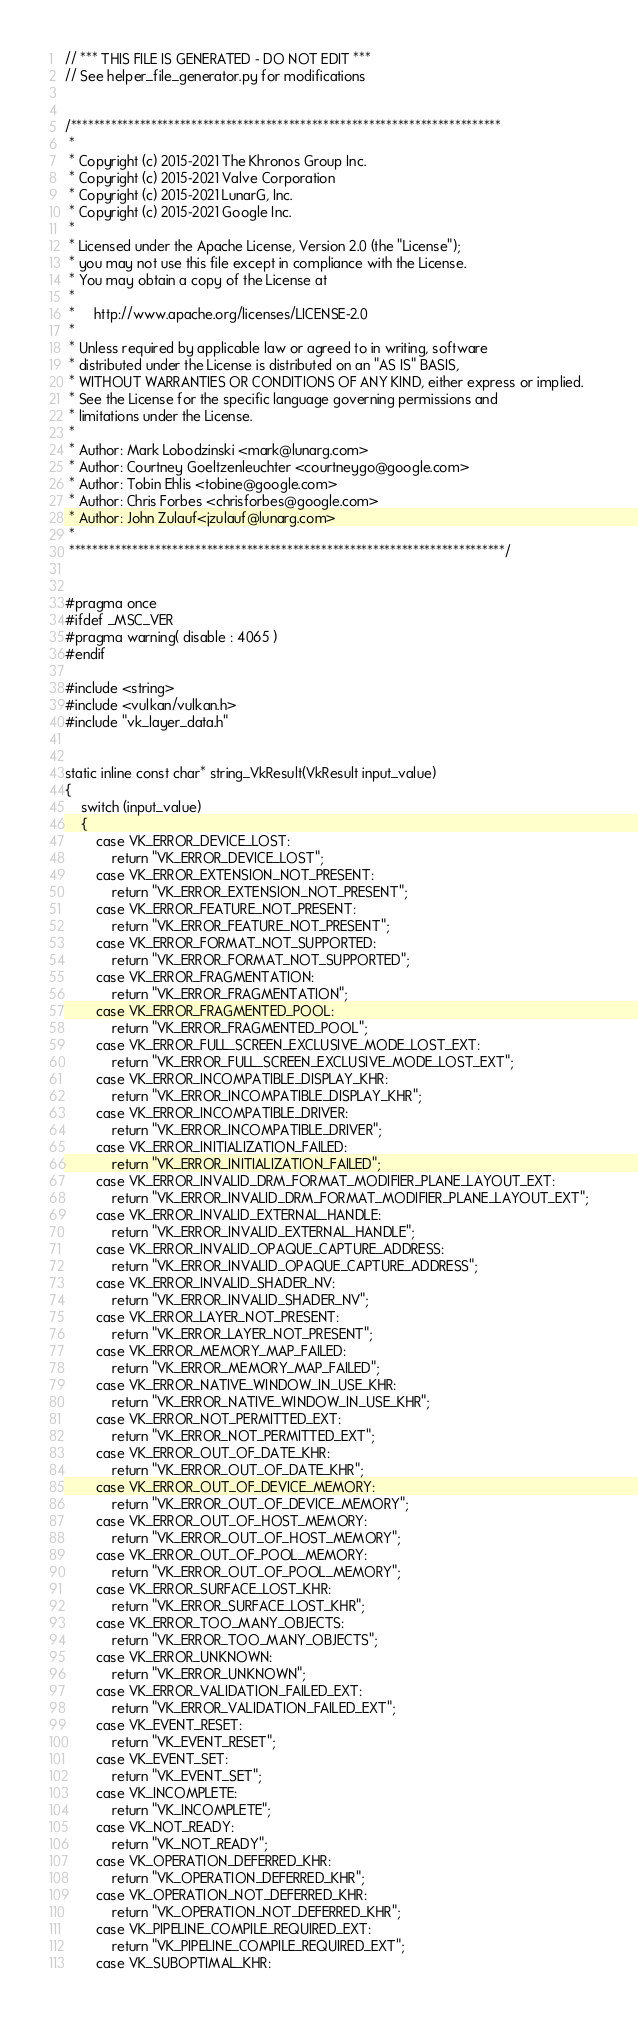Convert code to text. <code><loc_0><loc_0><loc_500><loc_500><_C_>// *** THIS FILE IS GENERATED - DO NOT EDIT ***
// See helper_file_generator.py for modifications


/***************************************************************************
 *
 * Copyright (c) 2015-2021 The Khronos Group Inc.
 * Copyright (c) 2015-2021 Valve Corporation
 * Copyright (c) 2015-2021 LunarG, Inc.
 * Copyright (c) 2015-2021 Google Inc.
 *
 * Licensed under the Apache License, Version 2.0 (the "License");
 * you may not use this file except in compliance with the License.
 * You may obtain a copy of the License at
 *
 *     http://www.apache.org/licenses/LICENSE-2.0
 *
 * Unless required by applicable law or agreed to in writing, software
 * distributed under the License is distributed on an "AS IS" BASIS,
 * WITHOUT WARRANTIES OR CONDITIONS OF ANY KIND, either express or implied.
 * See the License for the specific language governing permissions and
 * limitations under the License.
 *
 * Author: Mark Lobodzinski <mark@lunarg.com>
 * Author: Courtney Goeltzenleuchter <courtneygo@google.com>
 * Author: Tobin Ehlis <tobine@google.com>
 * Author: Chris Forbes <chrisforbes@google.com>
 * Author: John Zulauf<jzulauf@lunarg.com>
 *
 ****************************************************************************/


#pragma once
#ifdef _MSC_VER
#pragma warning( disable : 4065 )
#endif

#include <string>
#include <vulkan/vulkan.h>
#include "vk_layer_data.h"


static inline const char* string_VkResult(VkResult input_value)
{
    switch (input_value)
    {
        case VK_ERROR_DEVICE_LOST:
            return "VK_ERROR_DEVICE_LOST";
        case VK_ERROR_EXTENSION_NOT_PRESENT:
            return "VK_ERROR_EXTENSION_NOT_PRESENT";
        case VK_ERROR_FEATURE_NOT_PRESENT:
            return "VK_ERROR_FEATURE_NOT_PRESENT";
        case VK_ERROR_FORMAT_NOT_SUPPORTED:
            return "VK_ERROR_FORMAT_NOT_SUPPORTED";
        case VK_ERROR_FRAGMENTATION:
            return "VK_ERROR_FRAGMENTATION";
        case VK_ERROR_FRAGMENTED_POOL:
            return "VK_ERROR_FRAGMENTED_POOL";
        case VK_ERROR_FULL_SCREEN_EXCLUSIVE_MODE_LOST_EXT:
            return "VK_ERROR_FULL_SCREEN_EXCLUSIVE_MODE_LOST_EXT";
        case VK_ERROR_INCOMPATIBLE_DISPLAY_KHR:
            return "VK_ERROR_INCOMPATIBLE_DISPLAY_KHR";
        case VK_ERROR_INCOMPATIBLE_DRIVER:
            return "VK_ERROR_INCOMPATIBLE_DRIVER";
        case VK_ERROR_INITIALIZATION_FAILED:
            return "VK_ERROR_INITIALIZATION_FAILED";
        case VK_ERROR_INVALID_DRM_FORMAT_MODIFIER_PLANE_LAYOUT_EXT:
            return "VK_ERROR_INVALID_DRM_FORMAT_MODIFIER_PLANE_LAYOUT_EXT";
        case VK_ERROR_INVALID_EXTERNAL_HANDLE:
            return "VK_ERROR_INVALID_EXTERNAL_HANDLE";
        case VK_ERROR_INVALID_OPAQUE_CAPTURE_ADDRESS:
            return "VK_ERROR_INVALID_OPAQUE_CAPTURE_ADDRESS";
        case VK_ERROR_INVALID_SHADER_NV:
            return "VK_ERROR_INVALID_SHADER_NV";
        case VK_ERROR_LAYER_NOT_PRESENT:
            return "VK_ERROR_LAYER_NOT_PRESENT";
        case VK_ERROR_MEMORY_MAP_FAILED:
            return "VK_ERROR_MEMORY_MAP_FAILED";
        case VK_ERROR_NATIVE_WINDOW_IN_USE_KHR:
            return "VK_ERROR_NATIVE_WINDOW_IN_USE_KHR";
        case VK_ERROR_NOT_PERMITTED_EXT:
            return "VK_ERROR_NOT_PERMITTED_EXT";
        case VK_ERROR_OUT_OF_DATE_KHR:
            return "VK_ERROR_OUT_OF_DATE_KHR";
        case VK_ERROR_OUT_OF_DEVICE_MEMORY:
            return "VK_ERROR_OUT_OF_DEVICE_MEMORY";
        case VK_ERROR_OUT_OF_HOST_MEMORY:
            return "VK_ERROR_OUT_OF_HOST_MEMORY";
        case VK_ERROR_OUT_OF_POOL_MEMORY:
            return "VK_ERROR_OUT_OF_POOL_MEMORY";
        case VK_ERROR_SURFACE_LOST_KHR:
            return "VK_ERROR_SURFACE_LOST_KHR";
        case VK_ERROR_TOO_MANY_OBJECTS:
            return "VK_ERROR_TOO_MANY_OBJECTS";
        case VK_ERROR_UNKNOWN:
            return "VK_ERROR_UNKNOWN";
        case VK_ERROR_VALIDATION_FAILED_EXT:
            return "VK_ERROR_VALIDATION_FAILED_EXT";
        case VK_EVENT_RESET:
            return "VK_EVENT_RESET";
        case VK_EVENT_SET:
            return "VK_EVENT_SET";
        case VK_INCOMPLETE:
            return "VK_INCOMPLETE";
        case VK_NOT_READY:
            return "VK_NOT_READY";
        case VK_OPERATION_DEFERRED_KHR:
            return "VK_OPERATION_DEFERRED_KHR";
        case VK_OPERATION_NOT_DEFERRED_KHR:
            return "VK_OPERATION_NOT_DEFERRED_KHR";
        case VK_PIPELINE_COMPILE_REQUIRED_EXT:
            return "VK_PIPELINE_COMPILE_REQUIRED_EXT";
        case VK_SUBOPTIMAL_KHR:</code> 